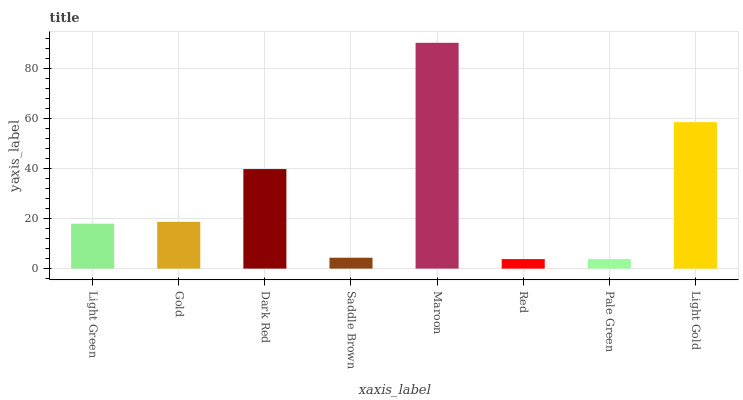Is Pale Green the minimum?
Answer yes or no. Yes. Is Maroon the maximum?
Answer yes or no. Yes. Is Gold the minimum?
Answer yes or no. No. Is Gold the maximum?
Answer yes or no. No. Is Gold greater than Light Green?
Answer yes or no. Yes. Is Light Green less than Gold?
Answer yes or no. Yes. Is Light Green greater than Gold?
Answer yes or no. No. Is Gold less than Light Green?
Answer yes or no. No. Is Gold the high median?
Answer yes or no. Yes. Is Light Green the low median?
Answer yes or no. Yes. Is Dark Red the high median?
Answer yes or no. No. Is Red the low median?
Answer yes or no. No. 